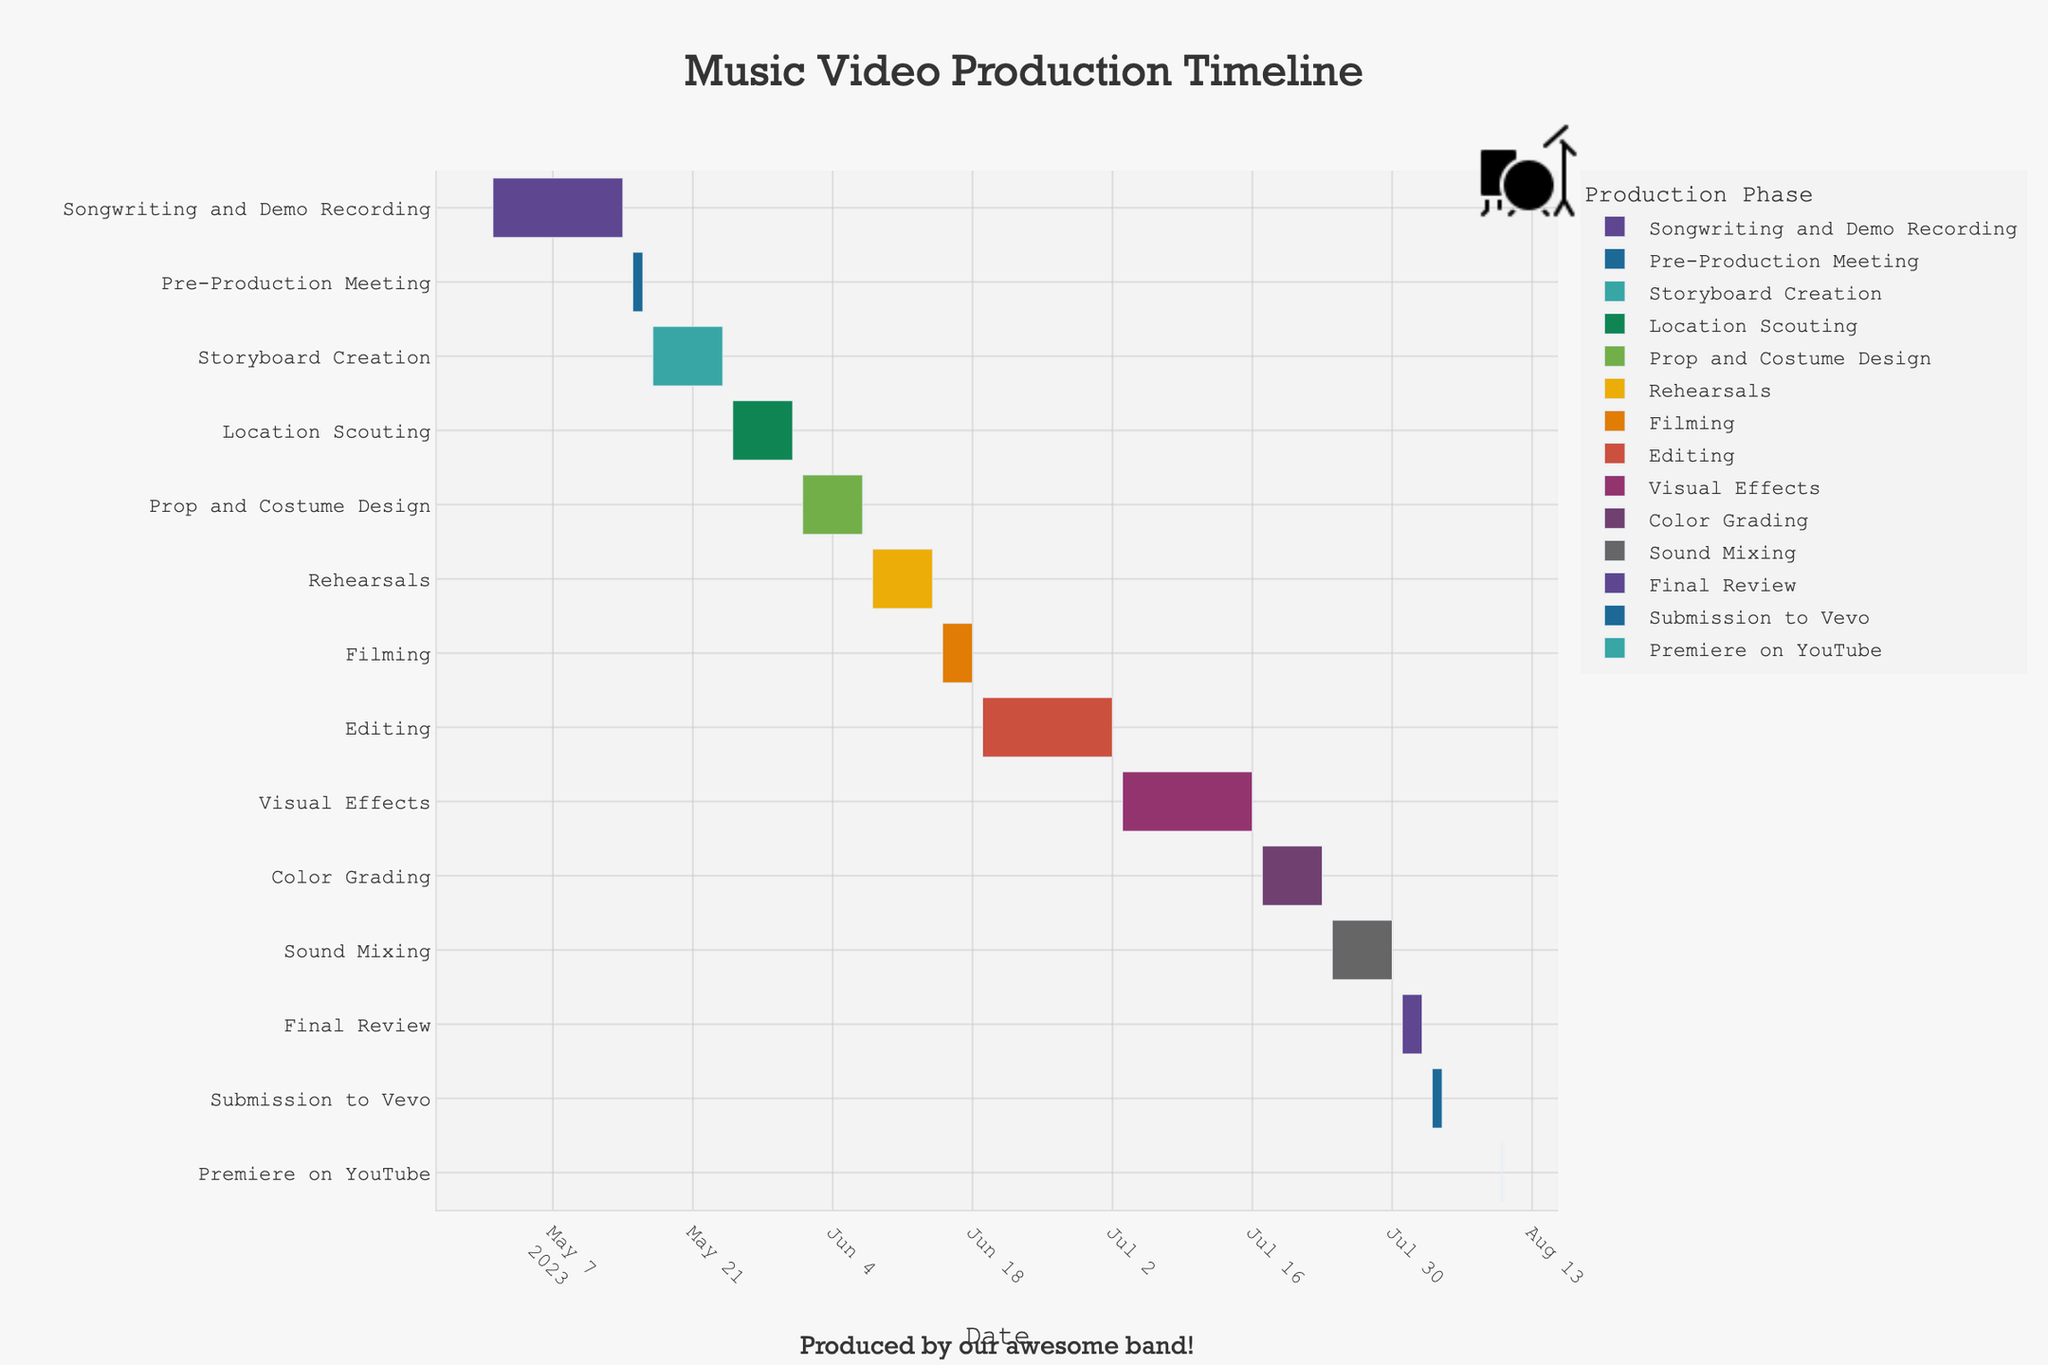What is the title of this Gantt chart? The title is located at the top of the figure and reads "Music Video Production Timeline," indicating the timeline for producing a music video.
Answer: Music Video Production Timeline When does the "Filming" phase start and end? By looking at the "Filming" task on the vertical axis, we can see its start and end dates on the horizontal axis, which are June 15 and June 18, respectively.
Answer: June 15 to June 18 Which phase lasts the longest, and how long does it last? By comparing the durations of all phases, "Editing" has the longest bar and lasts from June 19 to July 2. Subtracting the start date from the end date: July 2 - June 19 = 13 days.
Answer: Editing, 13 days What's the shortest phase, and what's its duration? The shortest phase is "Pre-Production Meeting," which spans from May 15 to May 16. Subtracting the start date from the end date: May 16 - May 15 = 1 day.
Answer: Pre-Production Meeting, 1 day How many phases occur in May? By checking the date range in May on the horizontal axis, there are four phases: "Songwriting and Demo Recording," "Pre-Production Meeting," "Storyboard Creation," and "Location Scouting."
Answer: Four phases Which phases overlap in the timeline? By examining bars that overlap horizontally, "Storyboard Creation" overlaps with "Location Scouting," and "Editing" overlaps with "Visual Effects."
Answer: Storyboard Creation and Location Scouting, Editing and Visual Effects What's the total duration of all the phases combined measured in days? Summing up the individual durations of each phase as indicated on the timeline:
(Songwriting and Demo Recording: 14 days) + (Pre-Production Meeting: 2 days) + (Storyboard Creation: 7 days) + (Location Scouting: 7 days) + (Prop and Costume Design: 7 days) + (Rehearsals: 7 days) + (Filming: 4 days) + (Editing: 14 days) + (Visual Effects: 14 days) + (Color Grading: 7 days) + (Sound Mixing: 7 days) + (Final Review: 3 days) + (Submission to Vevo: 2 days) + (Premiere on YouTube: 1 day) = 96 days
Answer: 96 days How many phases occur after the "Filming" phase? Looking at the timeline after June 18 (end of "Filming"), the phases are "Editing," "Visual Effects," "Color Grading," "Sound Mixing," "Final Review," "Submission to Vevo," and "Premiere on YouTube," totaling 7 phases.
Answer: Seven phases 